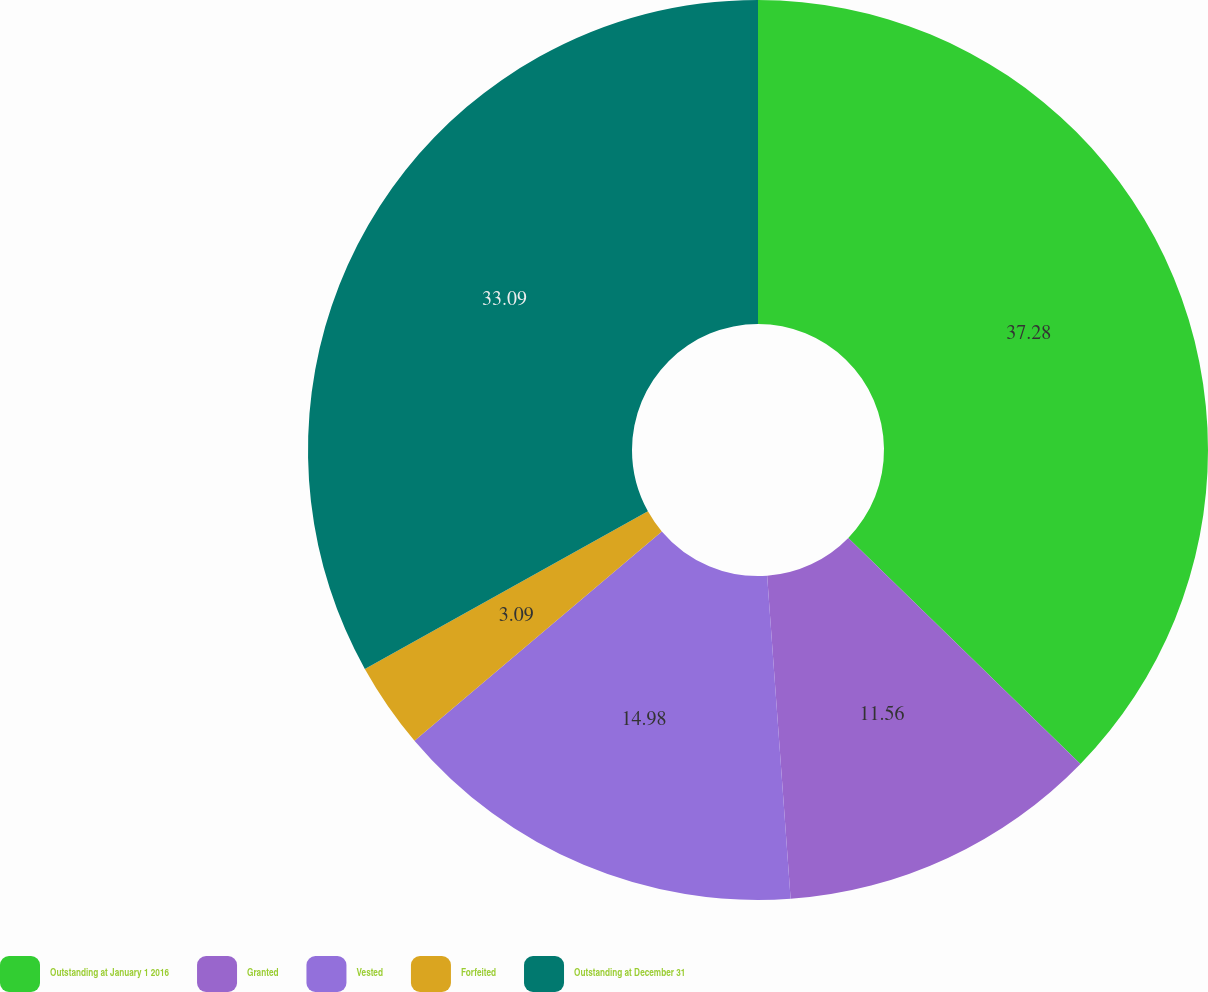Convert chart to OTSL. <chart><loc_0><loc_0><loc_500><loc_500><pie_chart><fcel>Outstanding at January 1 2016<fcel>Granted<fcel>Vested<fcel>Forfeited<fcel>Outstanding at December 31<nl><fcel>37.29%<fcel>11.56%<fcel>14.98%<fcel>3.09%<fcel>33.09%<nl></chart> 